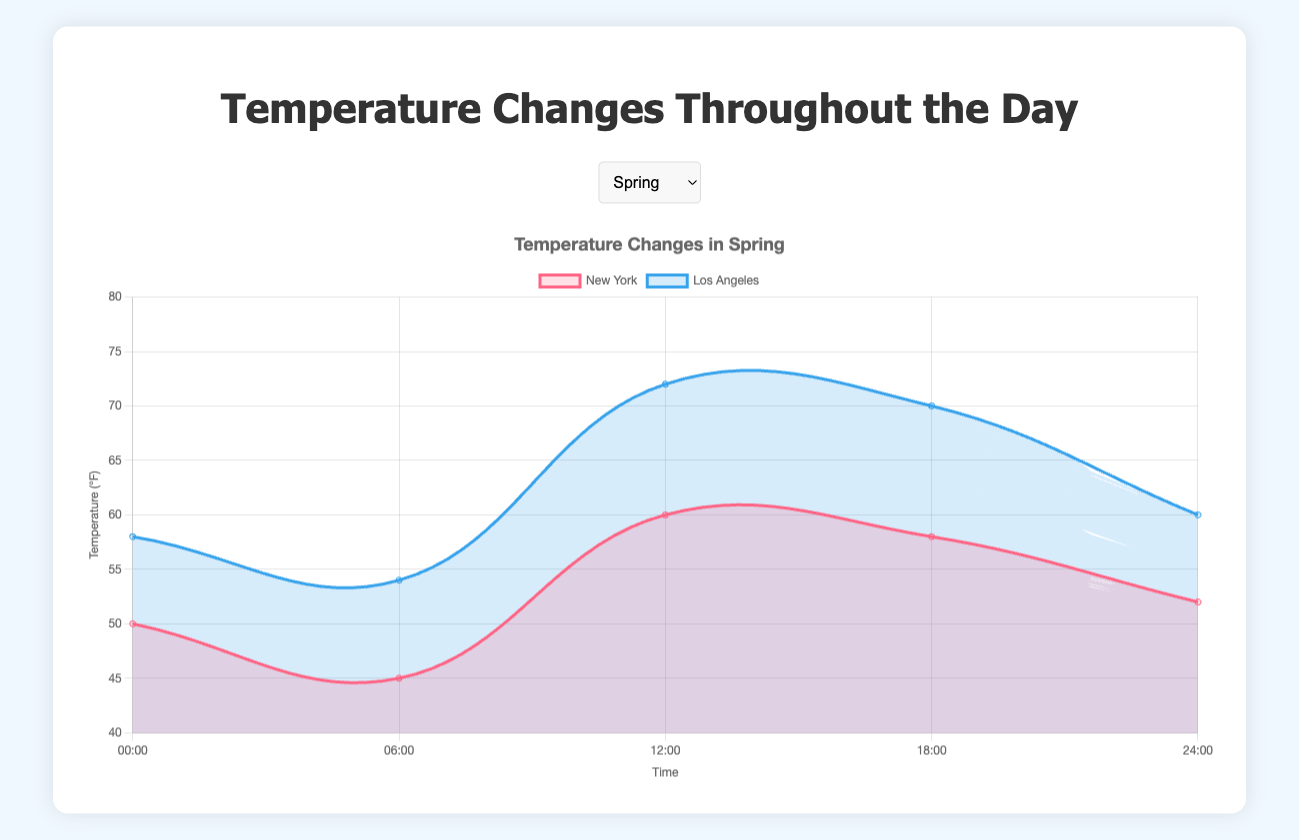Which season has the highest temperature recorded in any city? In the Summer season, Miami shows the highest recorded temperature at 88°F at 12:00pm. This is the highest temperature compared to other seasons.
Answer: Summer In which season does Chicago have the smallest morning temperature difference? In the Summer season, Chicago's temperatures at 6:00am and 12:00pm differ by 17°F (85°F - 68°F). Comparing with other cities, the temperature difference for Chicago in Summer is the smallest.
Answer: Summer Which city experiences the largest temperature change from midnight to noon in Winter? For Boston, the temperature changes from 25°F at 00:00 to 32°F at 12:00, a change of 7°F. For San Francisco, it changes from 48°F at 00:00 to 56°F at 12:00, a change of 8°F. San Francisco experiences the largest temperature change.
Answer: San Francisco In which season and city does the temperature remain the most steady throughout the day? Miami in Summer has a small temperature range from 77°F to 88°F. The difference between its highest and lowest temperatures is 11°F, which is smaller compared to other cities and seasons.
Answer: Summer, Miami Which city has the lowest temperature recorded at any time during the day in Winter? The lowest recorded temperature in Winter is 22°F in Boston at 6:00am.
Answer: Boston How does the temperature pattern in Seattle during Autumn compare to Denver in the same season? In Autumn, Seattle's temperatures range from 48°F to 62°F, while Denver's temperatures range from 54°F to 70°F. Denver has a higher temperature range and is generally warmer compared to Seattle.
Answer: Denver is warmer and has a higher temperature range Compare the temperature of New York and Los Angeles at noon during Spring. At noon in Spring, New York's temperature is 60°F, while Los Angeles's temperature is 72°F. Los Angeles is warmer at this time.
Answer: Los Angeles By how many degrees does the temperature decrease in Boston from noon to midnight in Winter? In Winter at noon, Boston's temperature is 32°F, and at midnight, it is 26°F. The decrease is 6°F (32°F - 26°F).
Answer: 6°F Which season shows the smallest temperature range throughout the day across all cities? The smallest temperature range is observed in the Winter season in San Francisco, ranging only from 45°F to 56°F, giving a range of 11°F.
Answer: Winter 